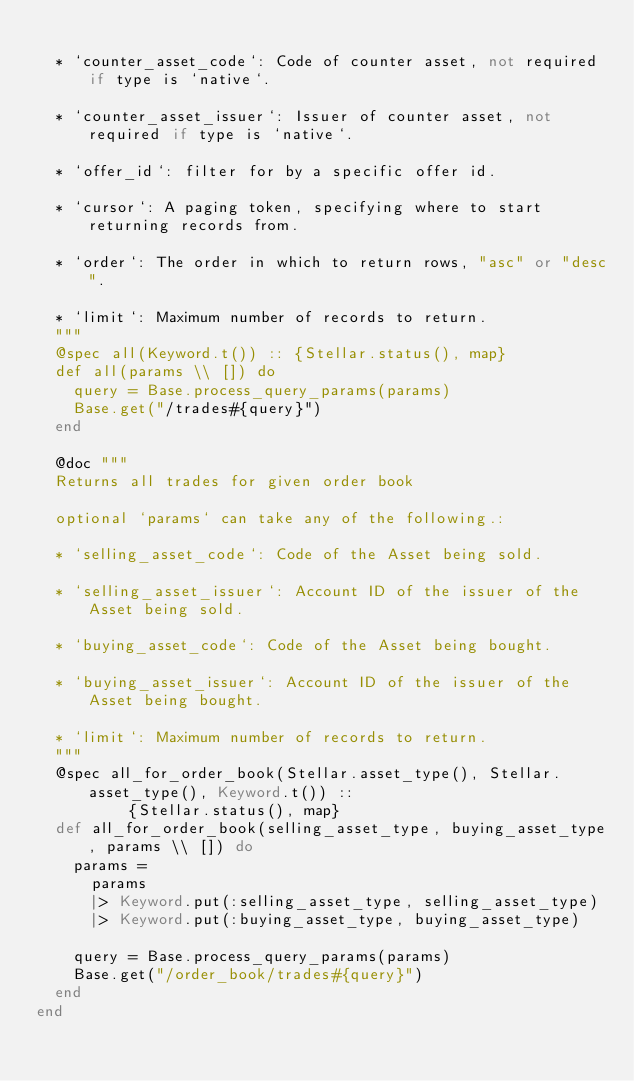Convert code to text. <code><loc_0><loc_0><loc_500><loc_500><_Elixir_>
  * `counter_asset_code`: Code of counter asset, not required if type is `native`.

  * `counter_asset_issuer`: Issuer of counter asset, not required if type is `native`.

  * `offer_id`: filter for by a specific offer id.

  * `cursor`: A paging token, specifying where to start returning records from.

  * `order`: The order in which to return rows, "asc" or "desc".

  * `limit`: Maximum number of records to return.
  """
  @spec all(Keyword.t()) :: {Stellar.status(), map}
  def all(params \\ []) do
    query = Base.process_query_params(params)
    Base.get("/trades#{query}")
  end

  @doc """
  Returns all trades for given order book

  optional `params` can take any of the following.:

  * `selling_asset_code`: Code of the Asset being sold.

  * `selling_asset_issuer`: Account ID of the issuer of the Asset being sold.

  * `buying_asset_code`: Code of the Asset being bought.

  * `buying_asset_issuer`: Account ID of the issuer of the Asset being bought.

  * `limit`: Maximum number of records to return.
  """
  @spec all_for_order_book(Stellar.asset_type(), Stellar.asset_type(), Keyword.t()) ::
          {Stellar.status(), map}
  def all_for_order_book(selling_asset_type, buying_asset_type, params \\ []) do
    params =
      params
      |> Keyword.put(:selling_asset_type, selling_asset_type)
      |> Keyword.put(:buying_asset_type, buying_asset_type)

    query = Base.process_query_params(params)
    Base.get("/order_book/trades#{query}")
  end
end
</code> 